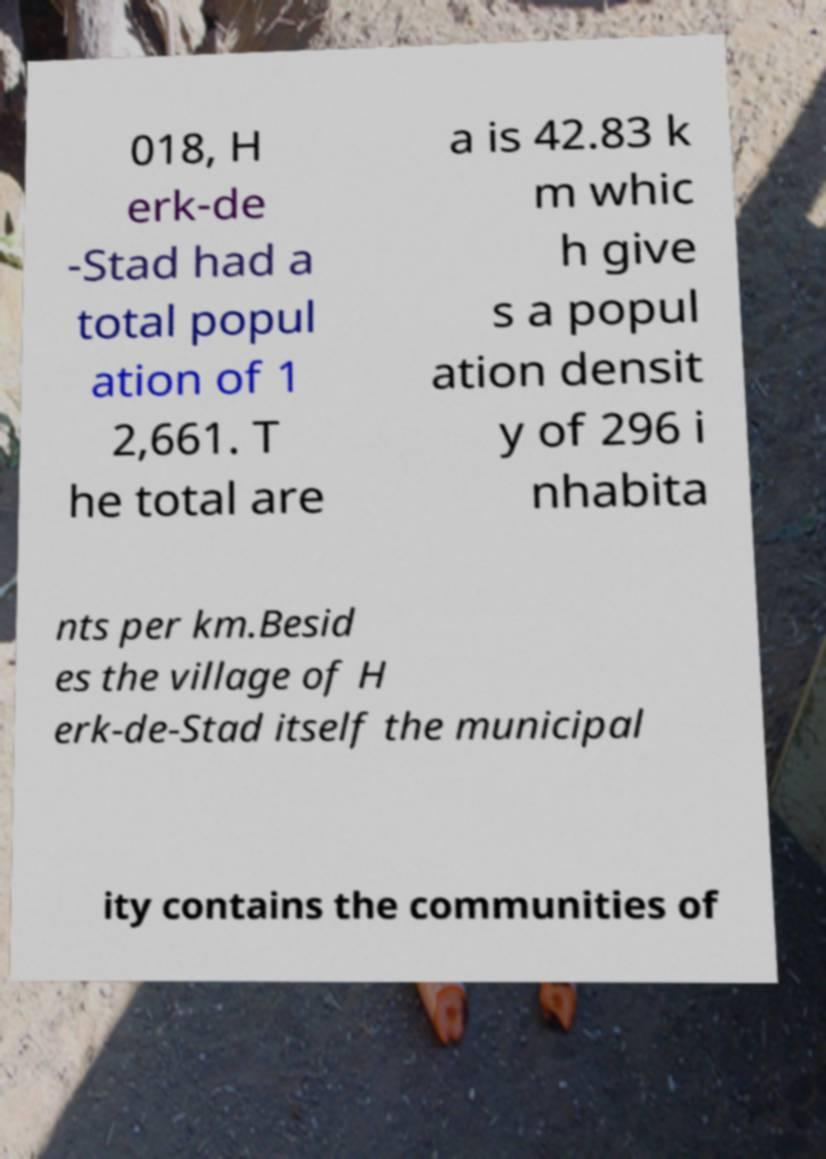Please identify and transcribe the text found in this image. 018, H erk-de -Stad had a total popul ation of 1 2,661. T he total are a is 42.83 k m whic h give s a popul ation densit y of 296 i nhabita nts per km.Besid es the village of H erk-de-Stad itself the municipal ity contains the communities of 